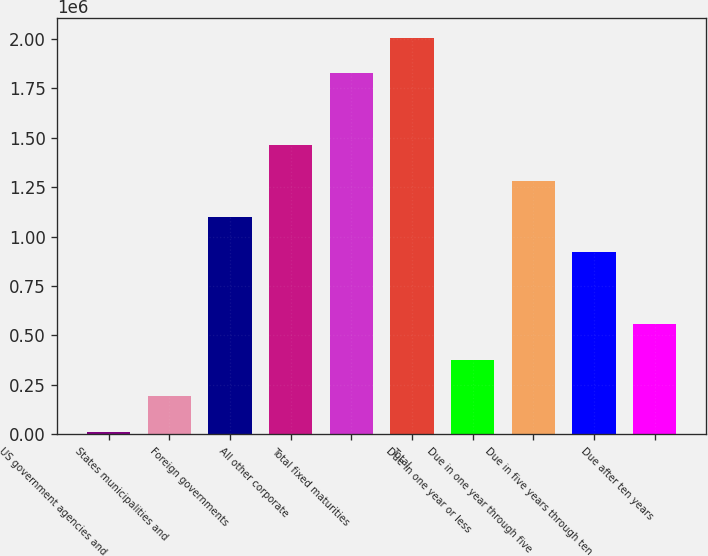Convert chart to OTSL. <chart><loc_0><loc_0><loc_500><loc_500><bar_chart><fcel>US government agencies and<fcel>States municipalities and<fcel>Foreign governments<fcel>All other corporate<fcel>Total fixed maturities<fcel>Total<fcel>Due in one year or less<fcel>Due in one year through five<fcel>Due in five years through ten<fcel>Due after ten years<nl><fcel>13150<fcel>194418<fcel>1.10076e+06<fcel>1.46329e+06<fcel>1.82582e+06<fcel>2.00709e+06<fcel>375685<fcel>1.28202e+06<fcel>919488<fcel>556952<nl></chart> 